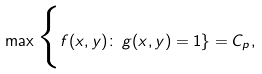<formula> <loc_0><loc_0><loc_500><loc_500>\max \Big \{ f ( x , y ) \colon \, g ( x , y ) = 1 \} = C _ { p } ,</formula> 